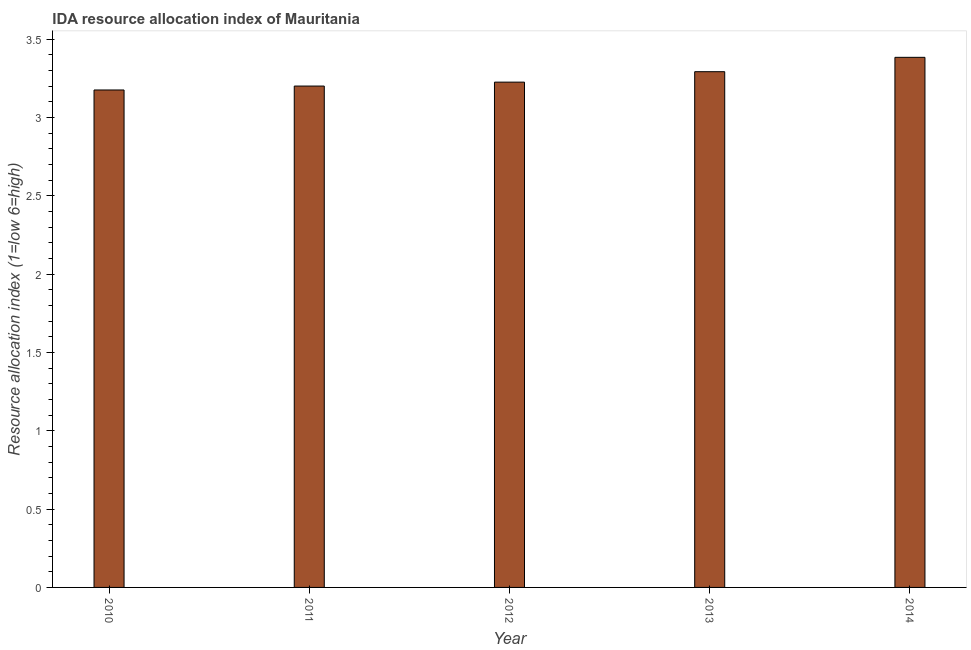What is the title of the graph?
Offer a very short reply. IDA resource allocation index of Mauritania. What is the label or title of the Y-axis?
Provide a short and direct response. Resource allocation index (1=low 6=high). What is the ida resource allocation index in 2013?
Keep it short and to the point. 3.29. Across all years, what is the maximum ida resource allocation index?
Ensure brevity in your answer.  3.38. Across all years, what is the minimum ida resource allocation index?
Provide a succinct answer. 3.17. What is the sum of the ida resource allocation index?
Give a very brief answer. 16.27. What is the difference between the ida resource allocation index in 2010 and 2014?
Offer a very short reply. -0.21. What is the average ida resource allocation index per year?
Keep it short and to the point. 3.25. What is the median ida resource allocation index?
Give a very brief answer. 3.23. Do a majority of the years between 2013 and 2012 (inclusive) have ida resource allocation index greater than 0.6 ?
Your answer should be very brief. No. What is the ratio of the ida resource allocation index in 2013 to that in 2014?
Give a very brief answer. 0.97. Is the difference between the ida resource allocation index in 2010 and 2011 greater than the difference between any two years?
Provide a succinct answer. No. What is the difference between the highest and the second highest ida resource allocation index?
Offer a terse response. 0.09. Is the sum of the ida resource allocation index in 2010 and 2013 greater than the maximum ida resource allocation index across all years?
Your response must be concise. Yes. What is the difference between the highest and the lowest ida resource allocation index?
Your response must be concise. 0.21. How many years are there in the graph?
Offer a very short reply. 5. What is the difference between two consecutive major ticks on the Y-axis?
Provide a succinct answer. 0.5. What is the Resource allocation index (1=low 6=high) in 2010?
Your answer should be compact. 3.17. What is the Resource allocation index (1=low 6=high) in 2011?
Your answer should be compact. 3.2. What is the Resource allocation index (1=low 6=high) of 2012?
Keep it short and to the point. 3.23. What is the Resource allocation index (1=low 6=high) of 2013?
Keep it short and to the point. 3.29. What is the Resource allocation index (1=low 6=high) of 2014?
Your answer should be compact. 3.38. What is the difference between the Resource allocation index (1=low 6=high) in 2010 and 2011?
Your answer should be compact. -0.03. What is the difference between the Resource allocation index (1=low 6=high) in 2010 and 2012?
Ensure brevity in your answer.  -0.05. What is the difference between the Resource allocation index (1=low 6=high) in 2010 and 2013?
Provide a succinct answer. -0.12. What is the difference between the Resource allocation index (1=low 6=high) in 2010 and 2014?
Offer a terse response. -0.21. What is the difference between the Resource allocation index (1=low 6=high) in 2011 and 2012?
Offer a very short reply. -0.03. What is the difference between the Resource allocation index (1=low 6=high) in 2011 and 2013?
Your response must be concise. -0.09. What is the difference between the Resource allocation index (1=low 6=high) in 2011 and 2014?
Your response must be concise. -0.18. What is the difference between the Resource allocation index (1=low 6=high) in 2012 and 2013?
Your response must be concise. -0.07. What is the difference between the Resource allocation index (1=low 6=high) in 2012 and 2014?
Provide a succinct answer. -0.16. What is the difference between the Resource allocation index (1=low 6=high) in 2013 and 2014?
Make the answer very short. -0.09. What is the ratio of the Resource allocation index (1=low 6=high) in 2010 to that in 2011?
Your answer should be compact. 0.99. What is the ratio of the Resource allocation index (1=low 6=high) in 2010 to that in 2012?
Give a very brief answer. 0.98. What is the ratio of the Resource allocation index (1=low 6=high) in 2010 to that in 2013?
Keep it short and to the point. 0.96. What is the ratio of the Resource allocation index (1=low 6=high) in 2010 to that in 2014?
Your answer should be very brief. 0.94. What is the ratio of the Resource allocation index (1=low 6=high) in 2011 to that in 2014?
Provide a succinct answer. 0.95. What is the ratio of the Resource allocation index (1=low 6=high) in 2012 to that in 2013?
Your response must be concise. 0.98. What is the ratio of the Resource allocation index (1=low 6=high) in 2012 to that in 2014?
Your answer should be very brief. 0.95. What is the ratio of the Resource allocation index (1=low 6=high) in 2013 to that in 2014?
Provide a short and direct response. 0.97. 